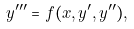Convert formula to latex. <formula><loc_0><loc_0><loc_500><loc_500>y ^ { \prime \prime \prime } = f ( x , y ^ { \prime } , y ^ { \prime \prime } ) ,</formula> 